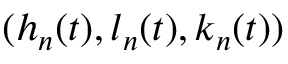Convert formula to latex. <formula><loc_0><loc_0><loc_500><loc_500>( h _ { n } ( t ) , l _ { n } ( t ) , k _ { n } ( t ) )</formula> 